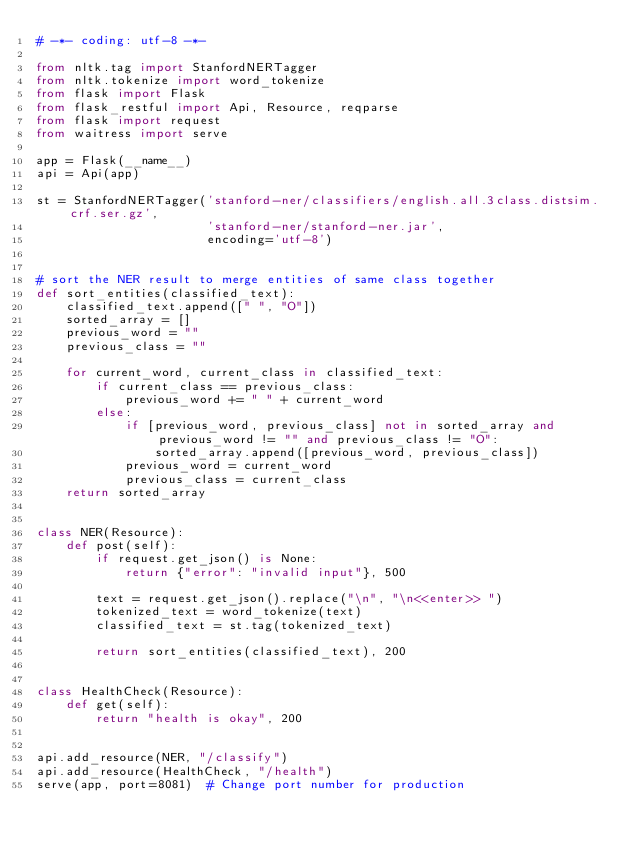<code> <loc_0><loc_0><loc_500><loc_500><_Python_># -*- coding: utf-8 -*-

from nltk.tag import StanfordNERTagger
from nltk.tokenize import word_tokenize
from flask import Flask
from flask_restful import Api, Resource, reqparse
from flask import request
from waitress import serve

app = Flask(__name__)
api = Api(app)

st = StanfordNERTagger('stanford-ner/classifiers/english.all.3class.distsim.crf.ser.gz',
                       'stanford-ner/stanford-ner.jar',
                       encoding='utf-8')


# sort the NER result to merge entities of same class together
def sort_entities(classified_text):
    classified_text.append([" ", "O"])
    sorted_array = []
    previous_word = ""
    previous_class = ""

    for current_word, current_class in classified_text:
        if current_class == previous_class:
            previous_word += " " + current_word
        else:
            if [previous_word, previous_class] not in sorted_array and previous_word != "" and previous_class != "O":
                sorted_array.append([previous_word, previous_class])
            previous_word = current_word
            previous_class = current_class
    return sorted_array


class NER(Resource):
    def post(self):
        if request.get_json() is None:
            return {"error": "invalid input"}, 500

        text = request.get_json().replace("\n", "\n<<enter>> ")
        tokenized_text = word_tokenize(text)
        classified_text = st.tag(tokenized_text)

        return sort_entities(classified_text), 200


class HealthCheck(Resource):
    def get(self):
        return "health is okay", 200


api.add_resource(NER, "/classify")
api.add_resource(HealthCheck, "/health")
serve(app, port=8081)  # Change port number for production
</code> 